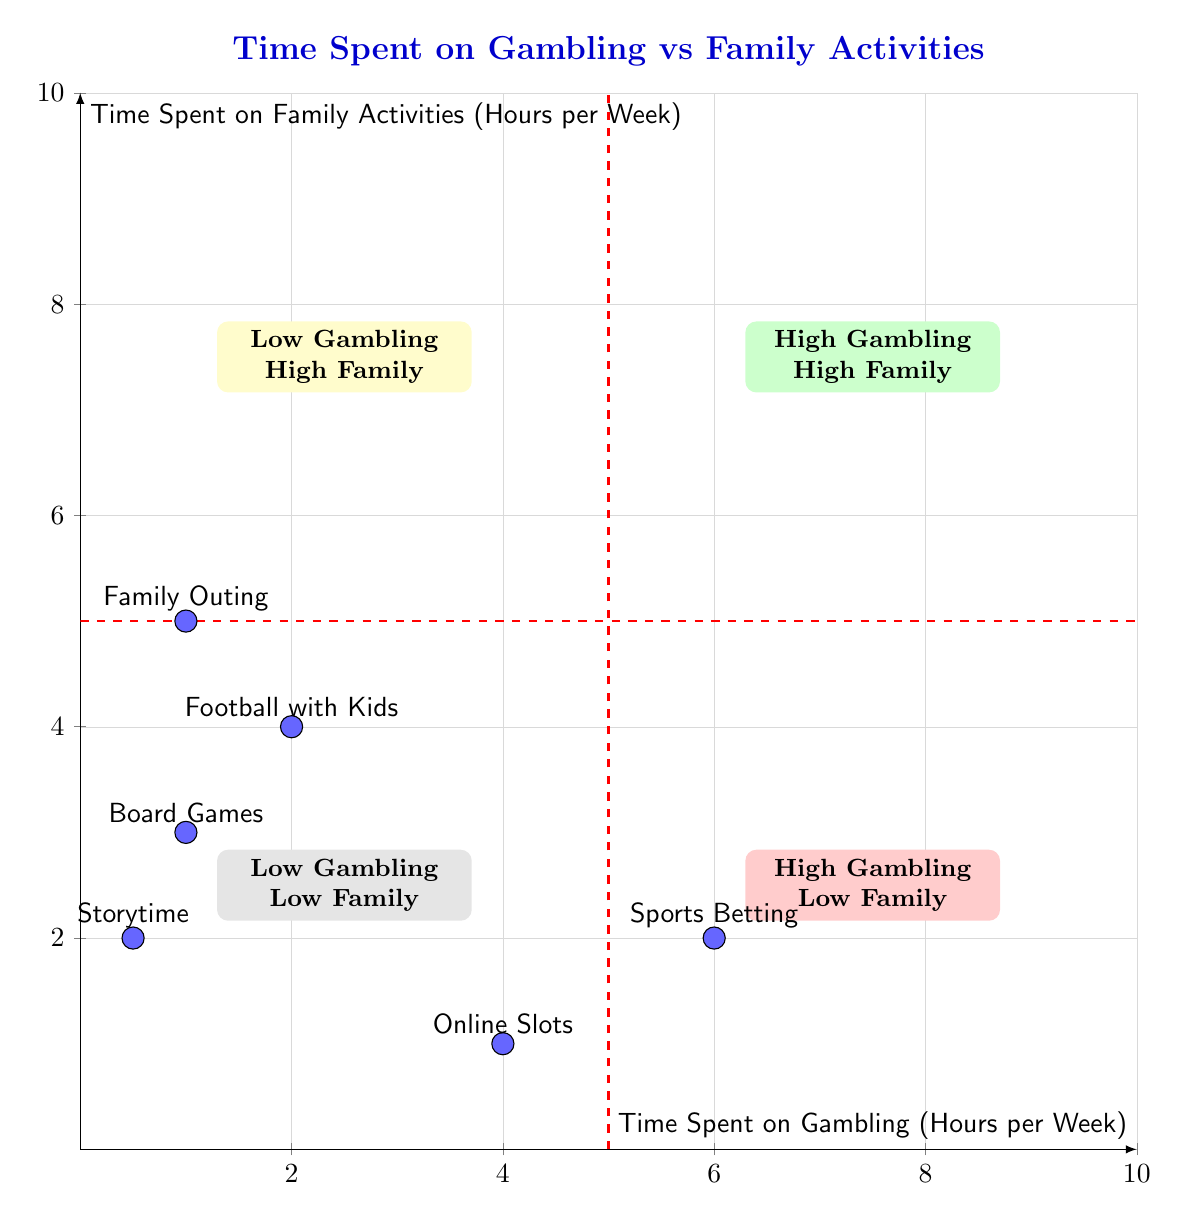What category does "Storytime with Kids" belong to? "Storytime with Kids" is listed among the family activities in the diagram, categorized specifically under 'Family Activities'.
Answer: Family Activities How many data points are plotted in the diagram? There are six distinct data points plotted in the diagram representing different activities related to gambling and family.
Answer: Six What is the gambling activity with the highest hours per week? The data indicates that "Sports Betting" has the highest hours per week at 6 hours, confirmed by its position in the diagram.
Answer: Sports Betting Where is "Family Outing" positioned on the quadrant chart? "Family Outing" is plotted at (1,5), placing it in the Low Gambling High Family quadrant, as it has low gambling hours and higher family activity hours.
Answer: Low Gambling High Family quadrant Which quadrant has the highest gambling and family activity hours? The quadrant titled "High Gambling & High Family Time" encompasses activities with significant hours in both areas, marked in green in the chart.
Answer: High Gambling & High Family Time How many family activities have more than 3 hours per week? "Football with Kids," "Board Games," and "Family Outing" each have 3 or more hours, amounting to three family activities total.
Answer: Three What is the total time spent on gambling activities as shown in the diagram? Adding the hours of "Sports Betting" (6) and "Online Slots" (4) gives a total of 10 hours per week spent on gambling activities.
Answer: Ten hours In which quadrant is "Online Slots Play" located? "Online Slots Play" is plotted at (4,1), which places it in the High Gambling Low Family quadrant as it signifies higher gambling time and less family engagement.
Answer: High Gambling Low Family quadrant What is the family activity with the least time spent? The activity with the least time, "Storytime with Kids," is shown with only 0.5 hours per week spent on it.
Answer: Storytime with Kids 